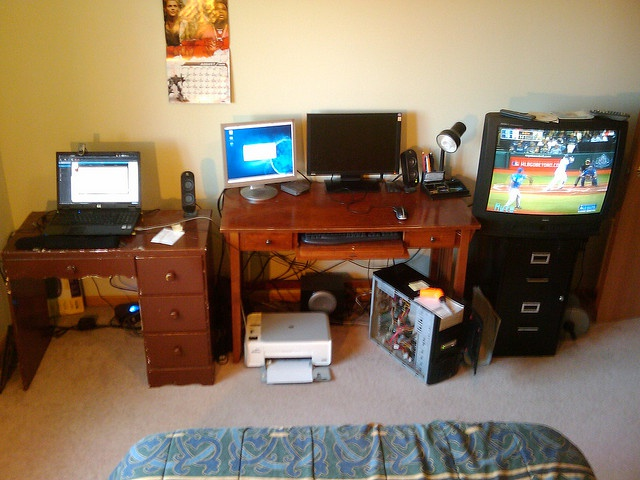Describe the objects in this image and their specific colors. I can see bed in olive, gray, and darkgray tones, dining table in olive, maroon, black, and brown tones, tv in olive, black, white, khaki, and gray tones, laptop in olive, black, white, and gray tones, and tv in olive, black, maroon, gray, and darkgray tones in this image. 